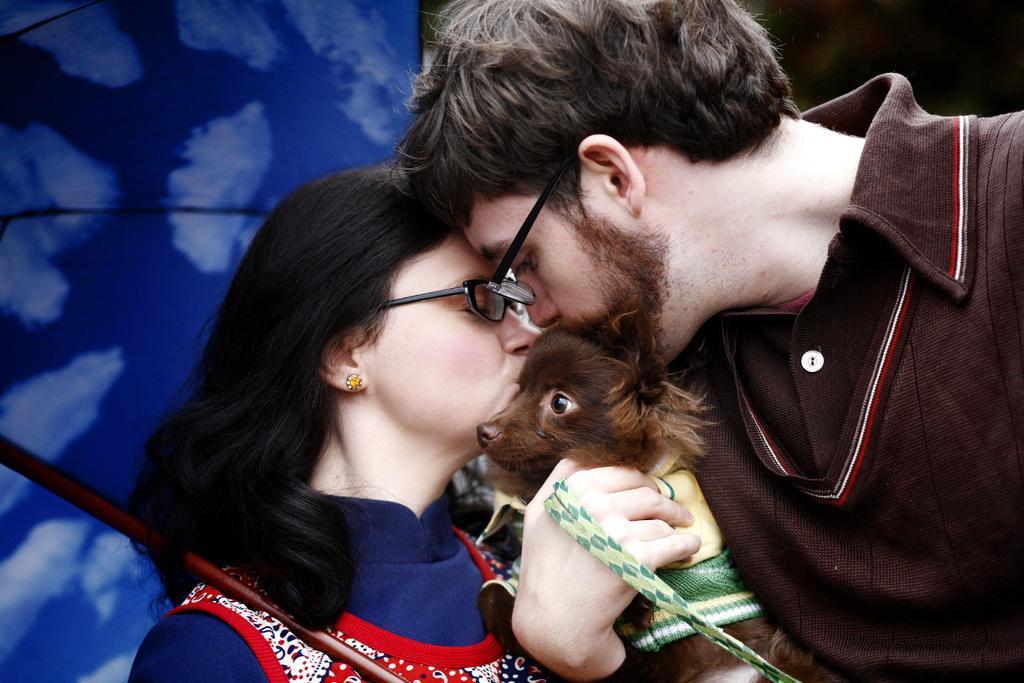Can you describe this image briefly? In this image, There are two persons standing and holding a dog which is in brown color, They both kissing the dog, In the background there is a blue color curtain. 